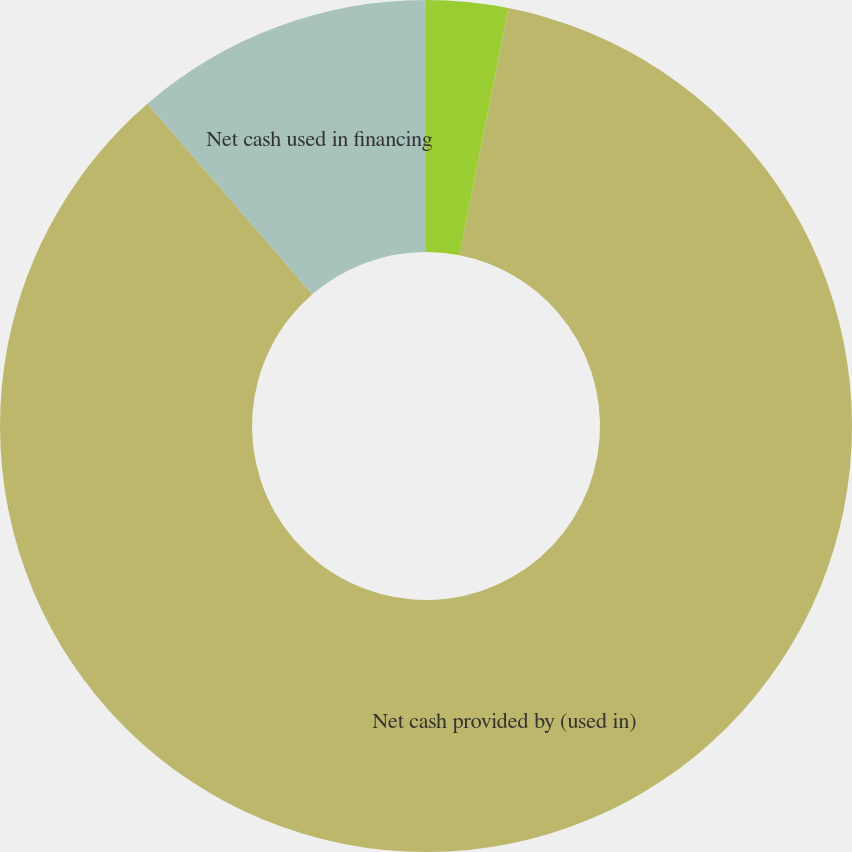Convert chart to OTSL. <chart><loc_0><loc_0><loc_500><loc_500><pie_chart><fcel>Net cash provided by operating<fcel>Net cash provided by (used in)<fcel>Net cash used in financing<nl><fcel>3.1%<fcel>85.56%<fcel>11.34%<nl></chart> 